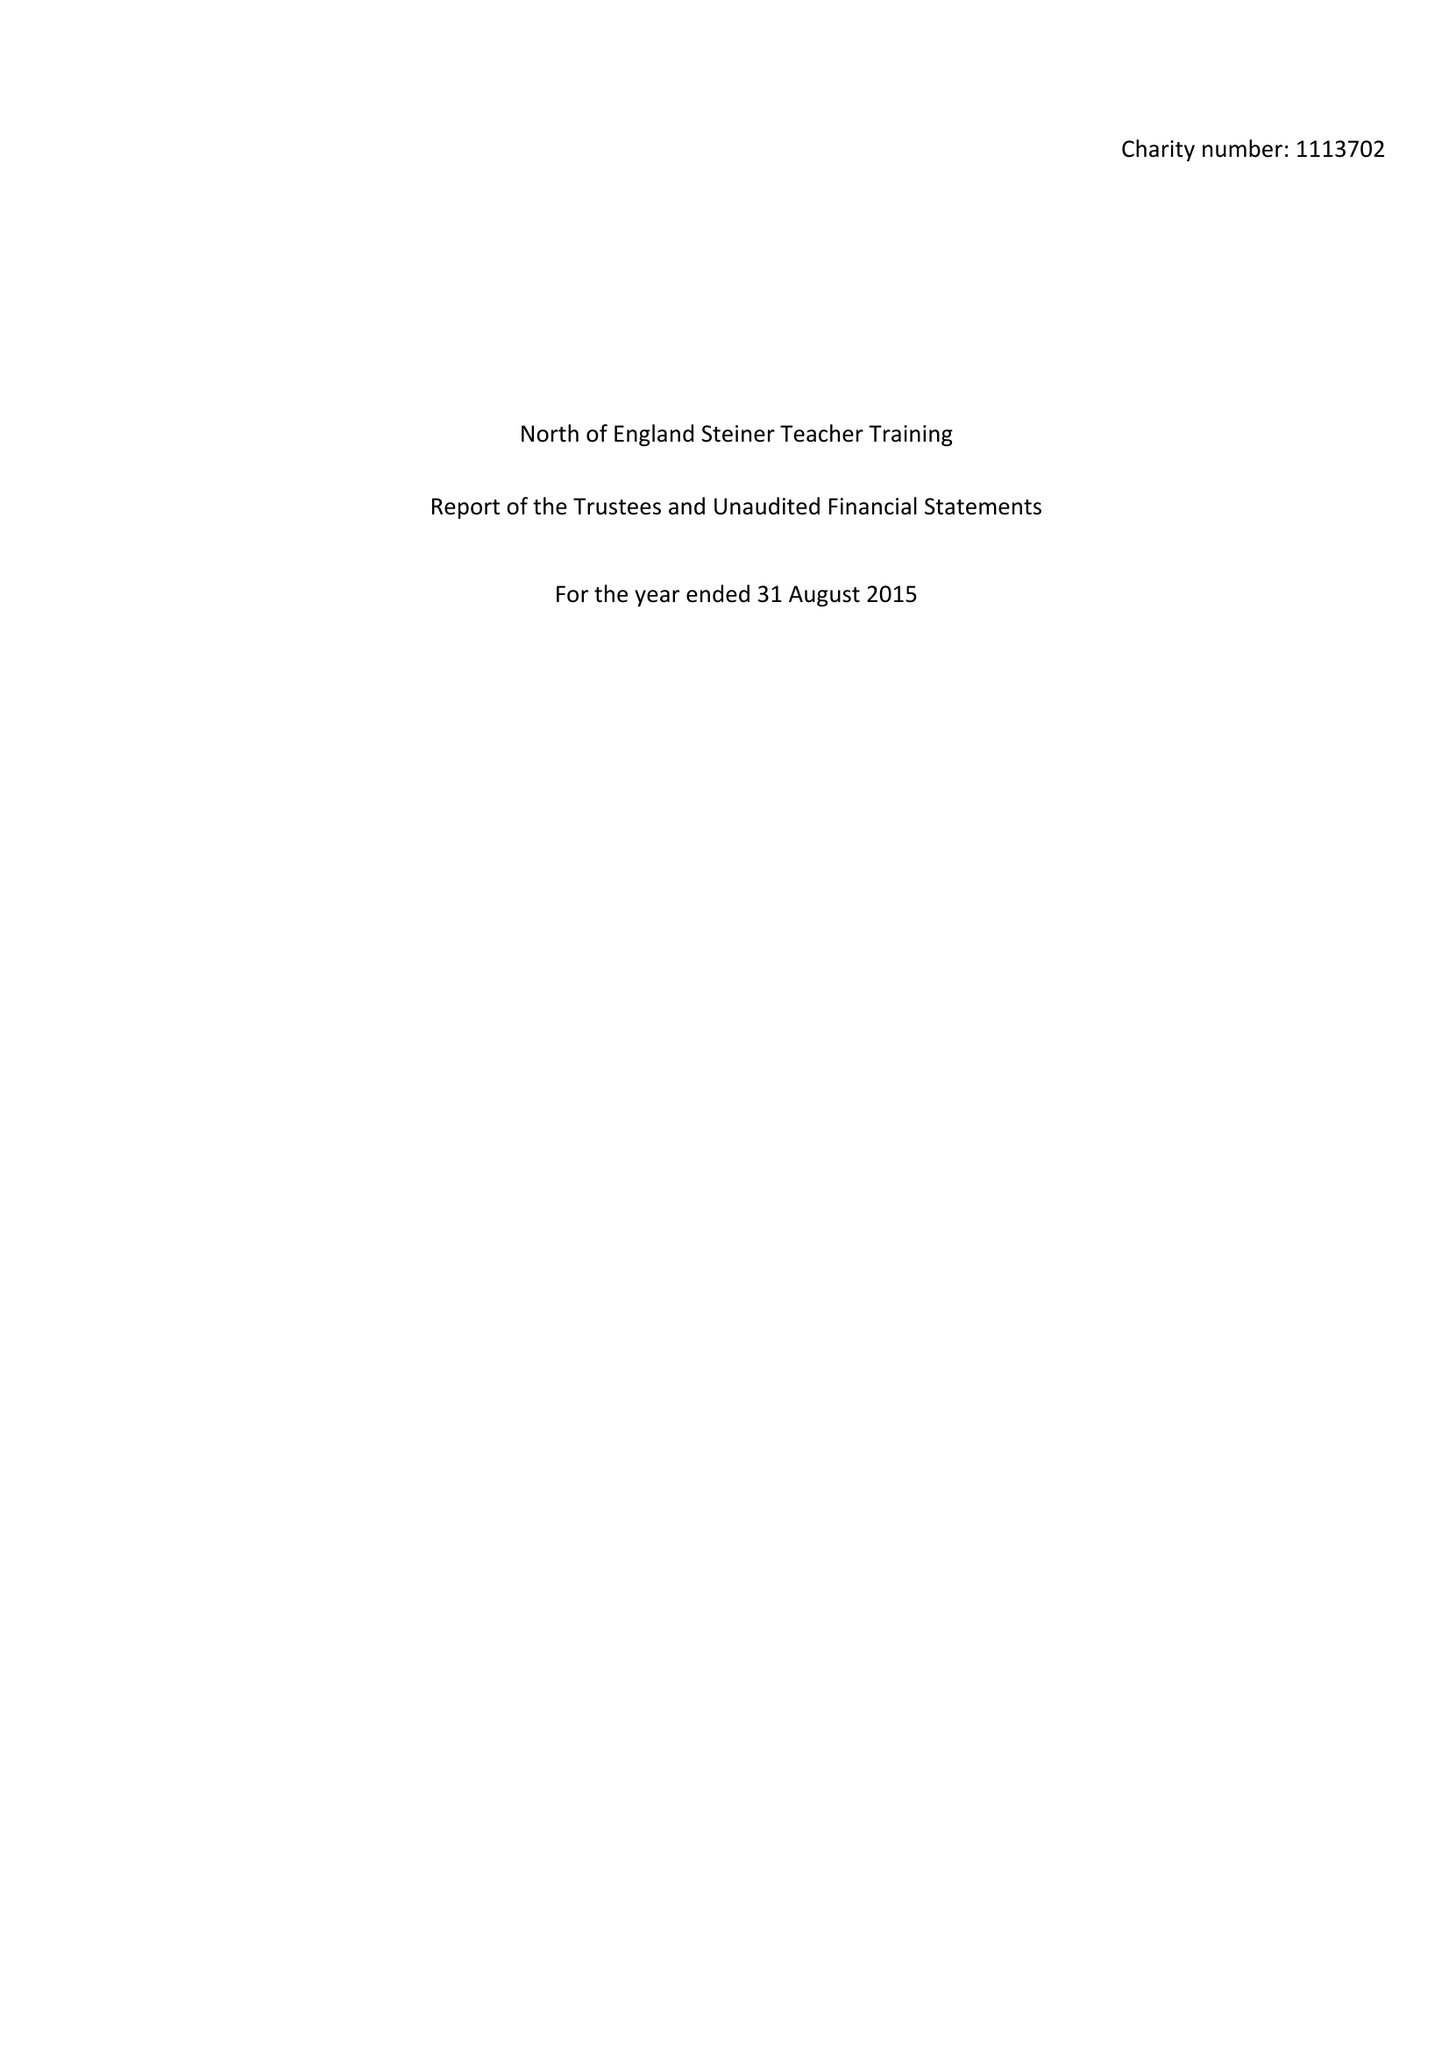What is the value for the spending_annually_in_british_pounds?
Answer the question using a single word or phrase. 64175.00 